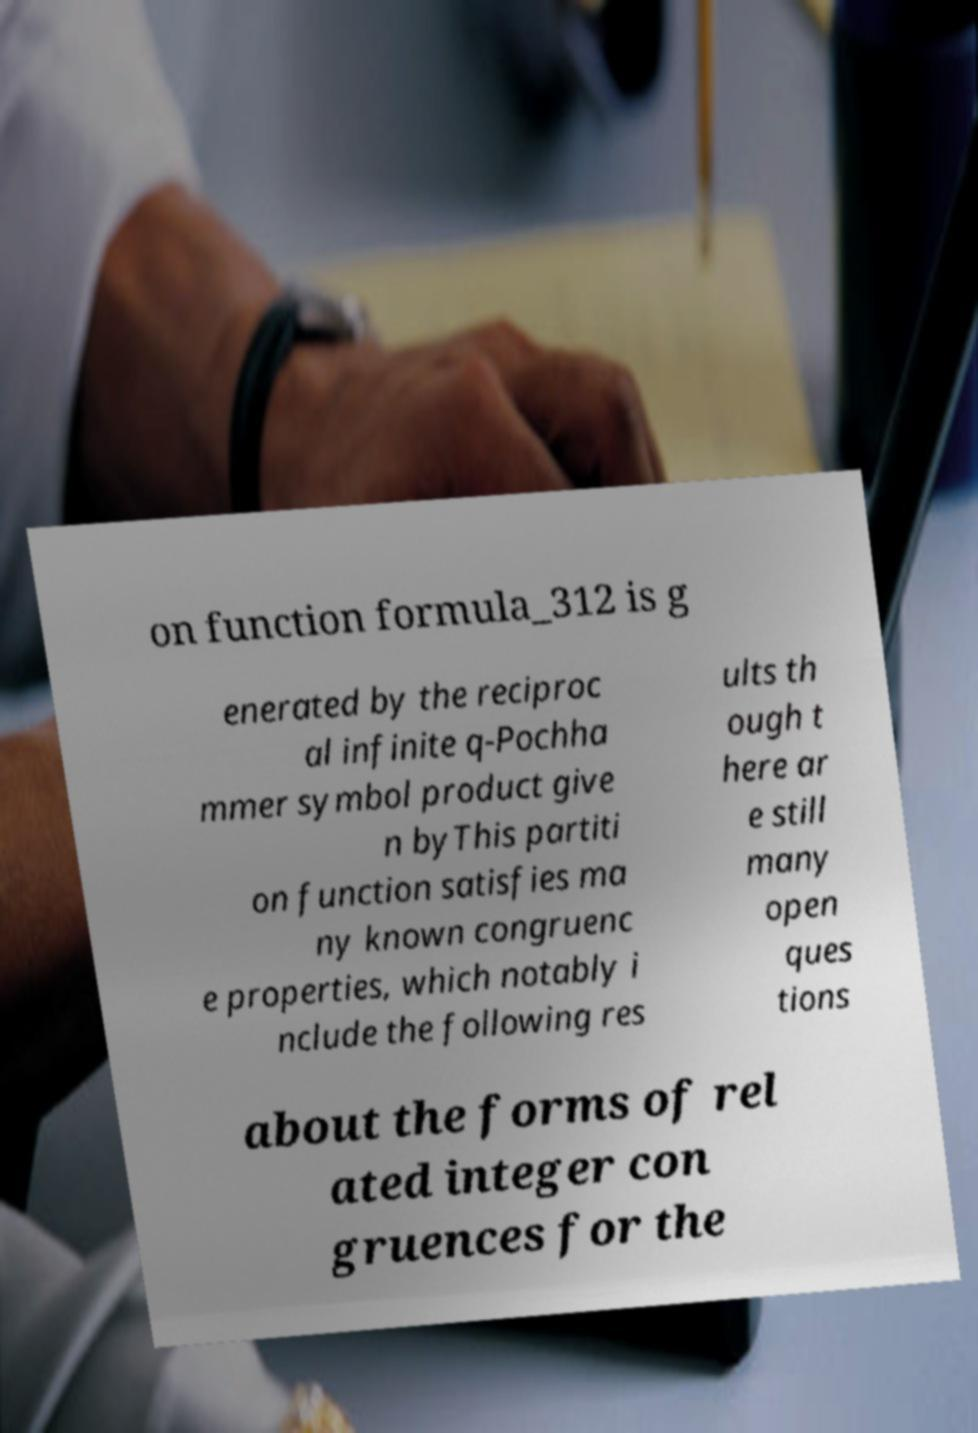Can you read and provide the text displayed in the image?This photo seems to have some interesting text. Can you extract and type it out for me? on function formula_312 is g enerated by the reciproc al infinite q-Pochha mmer symbol product give n byThis partiti on function satisfies ma ny known congruenc e properties, which notably i nclude the following res ults th ough t here ar e still many open ques tions about the forms of rel ated integer con gruences for the 